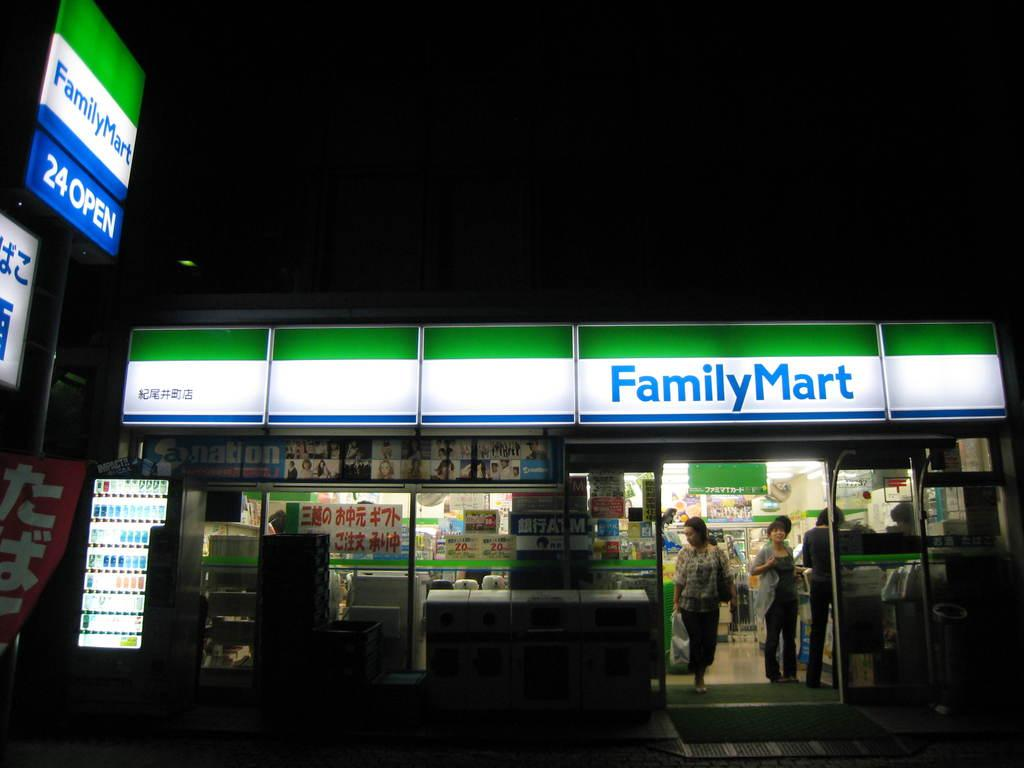<image>
Present a compact description of the photo's key features. Several people can be seen inside the Family Mart store. 